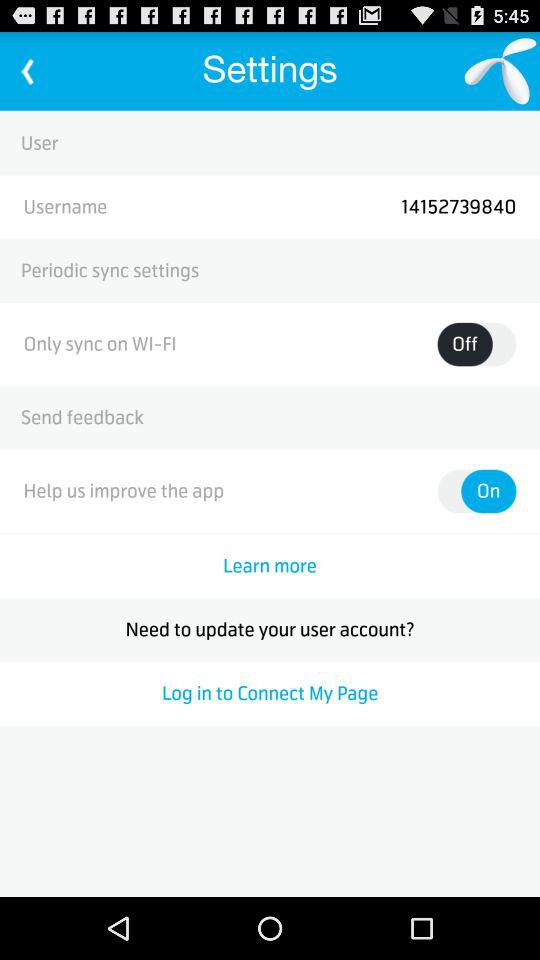What is the status of "Help us improve the app"? "Help us improve the app" is turned on. 